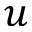<formula> <loc_0><loc_0><loc_500><loc_500>u</formula> 